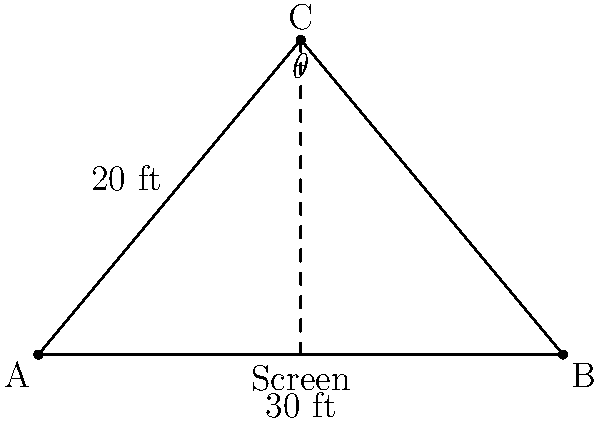In a movie theater, the screen is 30 feet wide, and you're sitting 20 feet away from the center of the screen. What is the viewing angle $\theta$ (in degrees) from your seat to the edges of the screen? Let's approach this step-by-step:

1) The situation forms a triangle. You are at point C, and the screen stretches from A to B.

2) We know:
   - The width of the screen (AB) is 30 feet
   - Your distance from the center of the screen (CD) is 20 feet

3) This forms an isosceles triangle, where AC = BC

4) We can split this into two right triangles. Let's focus on one:
   - The base (half of AB) is 15 feet
   - The height (CD) is 20 feet

5) We can use the arctangent function to find half of the viewing angle:
   $$\tan(\frac{\theta}{2}) = \frac{opposite}{adjacent} = \frac{15}{20}$$

6) Therefore:
   $$\frac{\theta}{2} = \arctan(\frac{15}{20})$$

7) To get the full angle, we multiply by 2:
   $$\theta = 2 \cdot \arctan(\frac{15}{20})$$

8) Calculate:
   $$\theta = 2 \cdot \arctan(0.75) \approx 73.74^\circ$$

9) Round to the nearest degree:
   $$\theta \approx 74^\circ$$
Answer: $74^\circ$ 